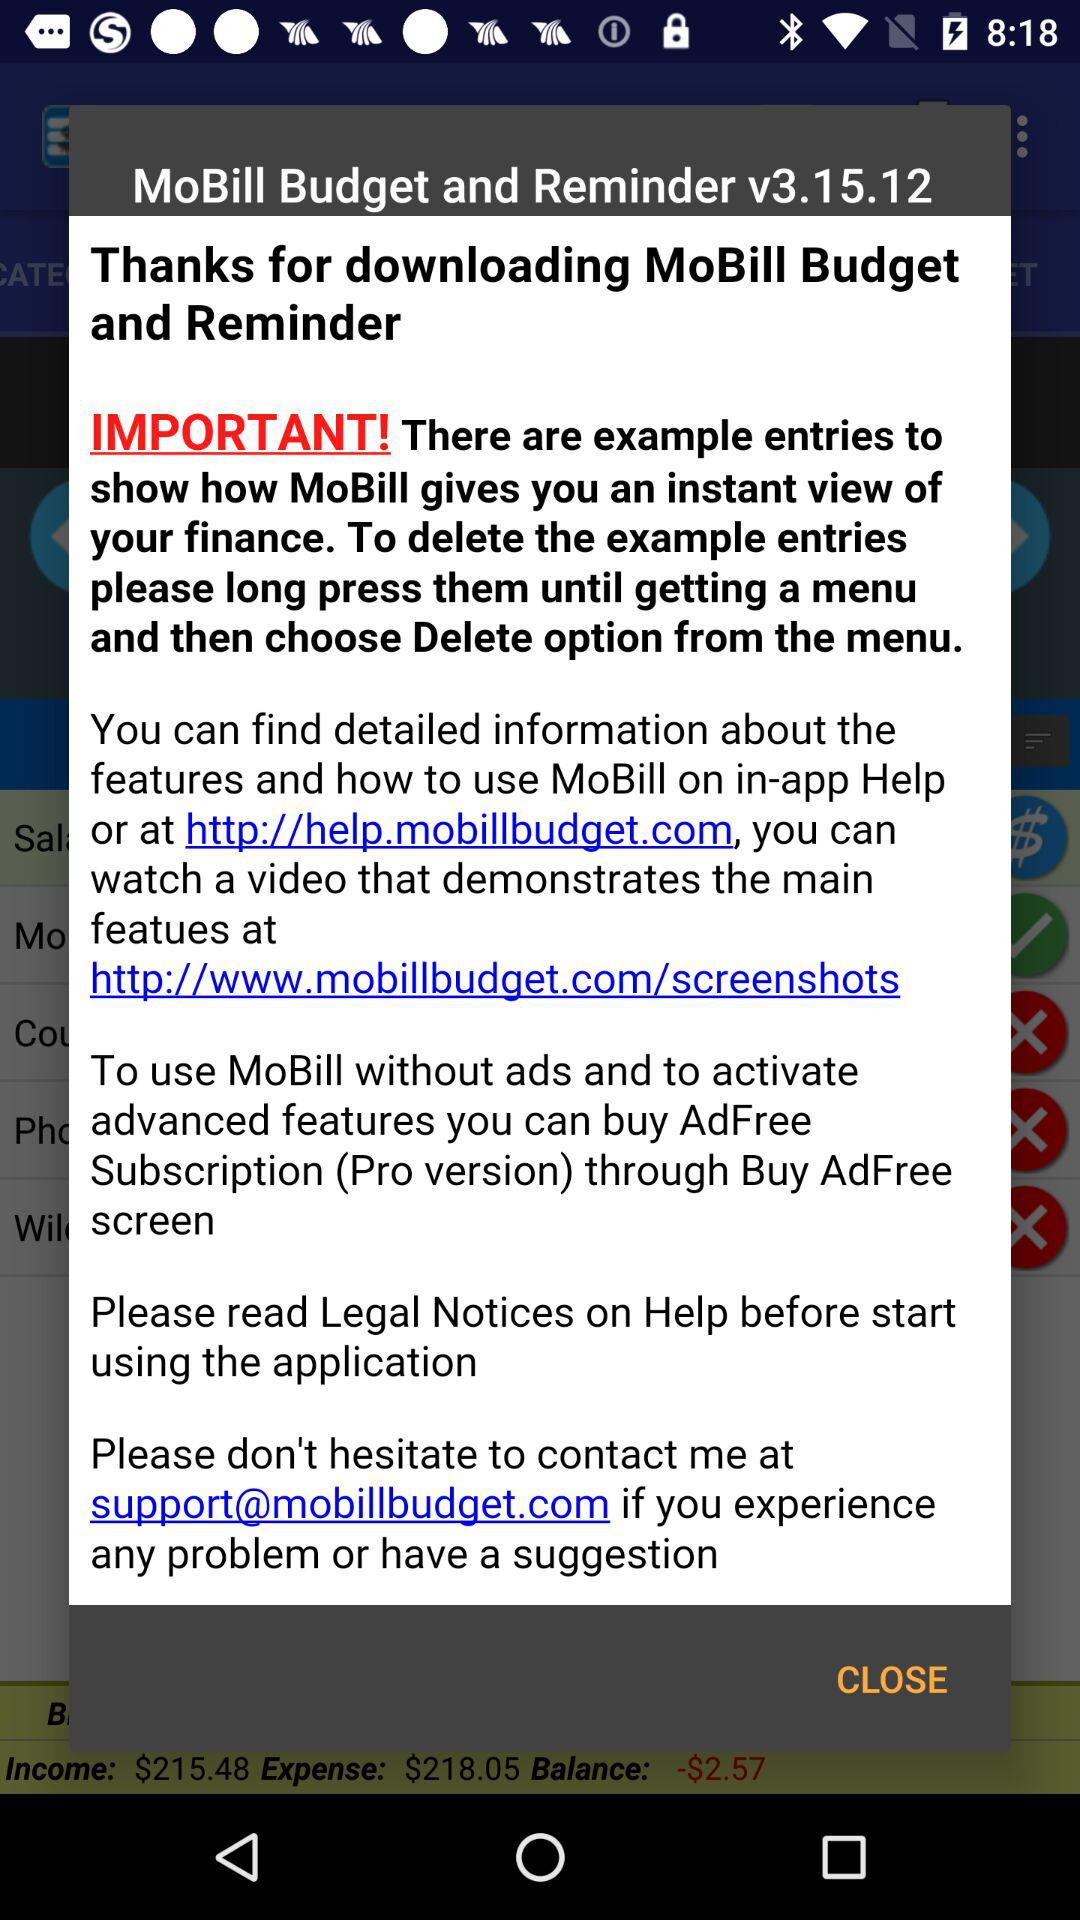How many links are there in the welcome screen?
Answer the question using a single word or phrase. 2 